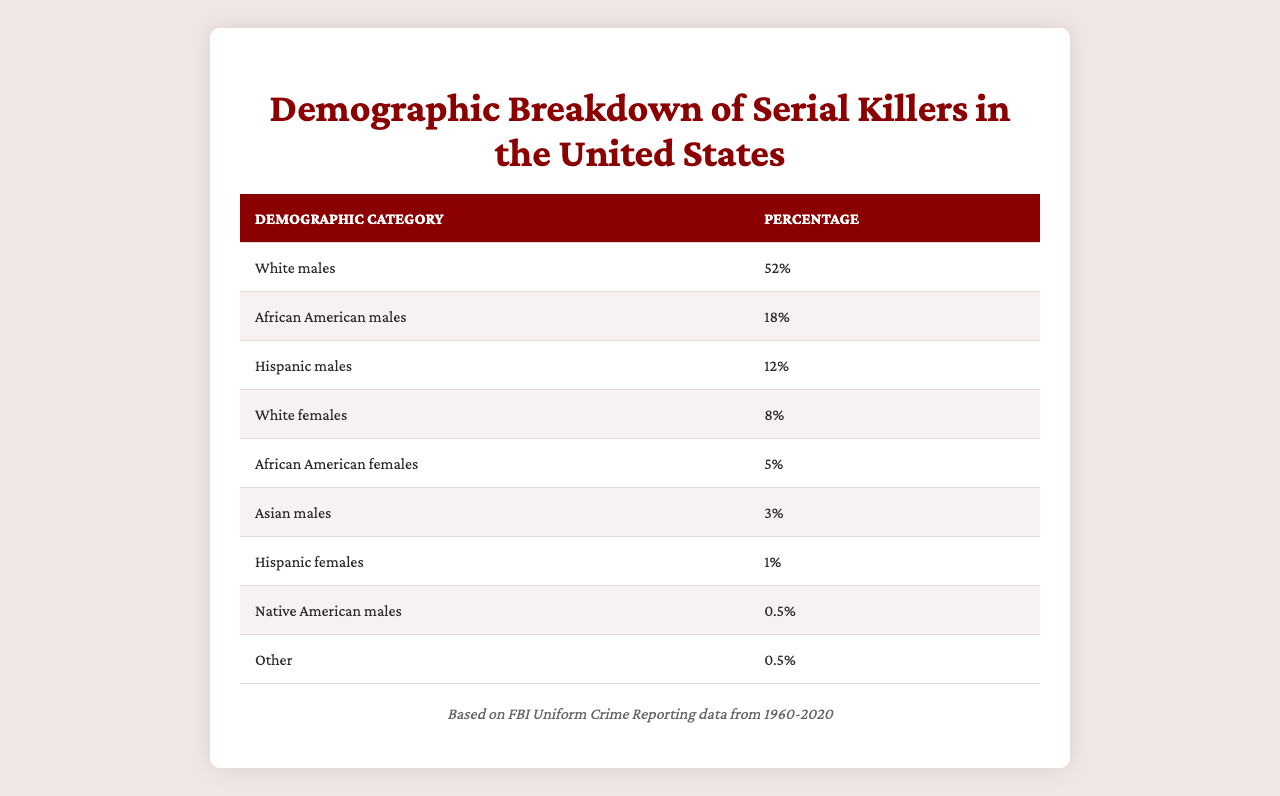What percentage of serial killers are White males? The table clearly shows that White males make up 52% of the demographic breakdown of serial killers in the United States.
Answer: 52% What is the combined percentage of African American males and Hispanic males among serial killers? To find the combined percentage, simply add the percentage of African American males (18%) to that of Hispanic males (12%). Thus, 18 + 12 = 30%.
Answer: 30% Is the percentage of Asian males among serial killers above 5%? According to the table, the percentage of Asian males is 3%, which is below 5%.
Answer: No Which demographic category has the lowest percentage of serial killers? By reviewing the table, we can see that both Native American males and Other categories have the lowest percentage at 0.5%.
Answer: Native American males and Other What is the difference in percentage between White males and White females among serial killers? The percentage of White males is 52%, and for White females, it is 8%. To find the difference, subtract 8 from 52, which gives us 44%.
Answer: 44% If we consider all females combined, what percentage of serial killers are female? Adding the percentages of White females (8%), African American females (5%), and Hispanic females (1%) gives us a total of 14% for females (8 + 5 + 1).
Answer: 14% What proportion of serial killers are not White males? To find this proportion, first determine the percentage of White males (52%) and then subtract this from 100%. Thus, 100 - 52 = 48%.
Answer: 48% Which racial demographic has the highest representation among serial killers? The table shows that White males have the highest representation at 52%, compared to other categories listed.
Answer: White males How many male categories have a percentage of 10% or higher? From the table, the categories that meet this criterion are White males (52%), African American males (18%), and Hispanic males (12%). Therefore, there are three male categories over 10%.
Answer: Three Are there more Hispanic males or Hispanic females among serial killers? Hispanic males have a percentage of 12% while Hispanic females have only 1%. Thus, Hispanic males outnumber Hispanic females.
Answer: Hispanic males 